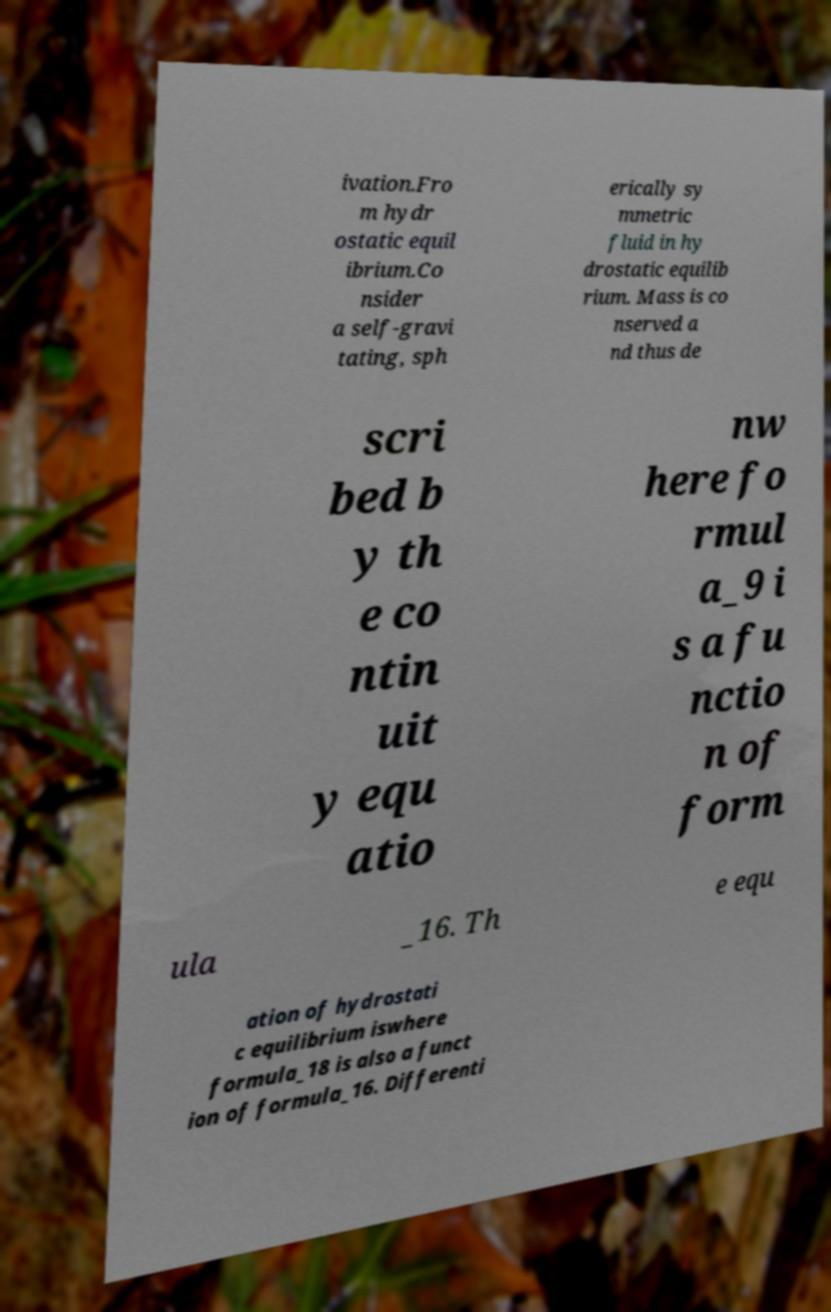Could you extract and type out the text from this image? ivation.Fro m hydr ostatic equil ibrium.Co nsider a self-gravi tating, sph erically sy mmetric fluid in hy drostatic equilib rium. Mass is co nserved a nd thus de scri bed b y th e co ntin uit y equ atio nw here fo rmul a_9 i s a fu nctio n of form ula _16. Th e equ ation of hydrostati c equilibrium iswhere formula_18 is also a funct ion of formula_16. Differenti 